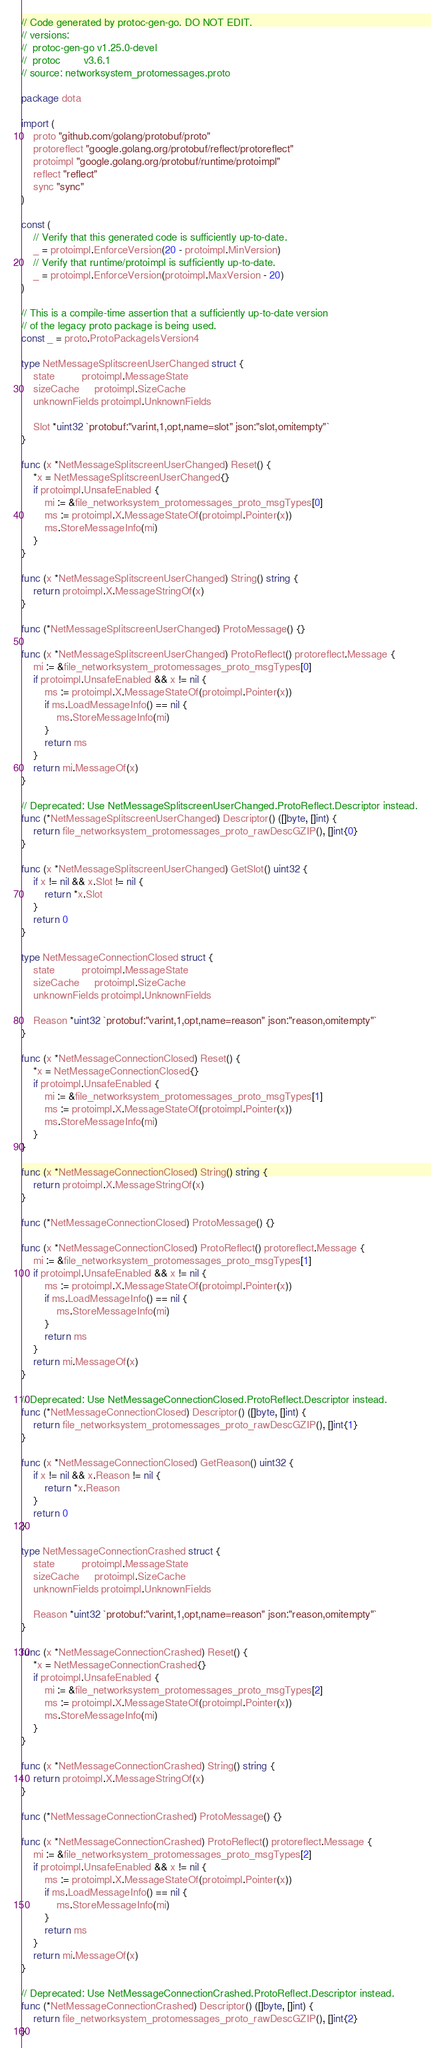<code> <loc_0><loc_0><loc_500><loc_500><_Go_>// Code generated by protoc-gen-go. DO NOT EDIT.
// versions:
// 	protoc-gen-go v1.25.0-devel
// 	protoc        v3.6.1
// source: networksystem_protomessages.proto

package dota

import (
	proto "github.com/golang/protobuf/proto"
	protoreflect "google.golang.org/protobuf/reflect/protoreflect"
	protoimpl "google.golang.org/protobuf/runtime/protoimpl"
	reflect "reflect"
	sync "sync"
)

const (
	// Verify that this generated code is sufficiently up-to-date.
	_ = protoimpl.EnforceVersion(20 - protoimpl.MinVersion)
	// Verify that runtime/protoimpl is sufficiently up-to-date.
	_ = protoimpl.EnforceVersion(protoimpl.MaxVersion - 20)
)

// This is a compile-time assertion that a sufficiently up-to-date version
// of the legacy proto package is being used.
const _ = proto.ProtoPackageIsVersion4

type NetMessageSplitscreenUserChanged struct {
	state         protoimpl.MessageState
	sizeCache     protoimpl.SizeCache
	unknownFields protoimpl.UnknownFields

	Slot *uint32 `protobuf:"varint,1,opt,name=slot" json:"slot,omitempty"`
}

func (x *NetMessageSplitscreenUserChanged) Reset() {
	*x = NetMessageSplitscreenUserChanged{}
	if protoimpl.UnsafeEnabled {
		mi := &file_networksystem_protomessages_proto_msgTypes[0]
		ms := protoimpl.X.MessageStateOf(protoimpl.Pointer(x))
		ms.StoreMessageInfo(mi)
	}
}

func (x *NetMessageSplitscreenUserChanged) String() string {
	return protoimpl.X.MessageStringOf(x)
}

func (*NetMessageSplitscreenUserChanged) ProtoMessage() {}

func (x *NetMessageSplitscreenUserChanged) ProtoReflect() protoreflect.Message {
	mi := &file_networksystem_protomessages_proto_msgTypes[0]
	if protoimpl.UnsafeEnabled && x != nil {
		ms := protoimpl.X.MessageStateOf(protoimpl.Pointer(x))
		if ms.LoadMessageInfo() == nil {
			ms.StoreMessageInfo(mi)
		}
		return ms
	}
	return mi.MessageOf(x)
}

// Deprecated: Use NetMessageSplitscreenUserChanged.ProtoReflect.Descriptor instead.
func (*NetMessageSplitscreenUserChanged) Descriptor() ([]byte, []int) {
	return file_networksystem_protomessages_proto_rawDescGZIP(), []int{0}
}

func (x *NetMessageSplitscreenUserChanged) GetSlot() uint32 {
	if x != nil && x.Slot != nil {
		return *x.Slot
	}
	return 0
}

type NetMessageConnectionClosed struct {
	state         protoimpl.MessageState
	sizeCache     protoimpl.SizeCache
	unknownFields protoimpl.UnknownFields

	Reason *uint32 `protobuf:"varint,1,opt,name=reason" json:"reason,omitempty"`
}

func (x *NetMessageConnectionClosed) Reset() {
	*x = NetMessageConnectionClosed{}
	if protoimpl.UnsafeEnabled {
		mi := &file_networksystem_protomessages_proto_msgTypes[1]
		ms := protoimpl.X.MessageStateOf(protoimpl.Pointer(x))
		ms.StoreMessageInfo(mi)
	}
}

func (x *NetMessageConnectionClosed) String() string {
	return protoimpl.X.MessageStringOf(x)
}

func (*NetMessageConnectionClosed) ProtoMessage() {}

func (x *NetMessageConnectionClosed) ProtoReflect() protoreflect.Message {
	mi := &file_networksystem_protomessages_proto_msgTypes[1]
	if protoimpl.UnsafeEnabled && x != nil {
		ms := protoimpl.X.MessageStateOf(protoimpl.Pointer(x))
		if ms.LoadMessageInfo() == nil {
			ms.StoreMessageInfo(mi)
		}
		return ms
	}
	return mi.MessageOf(x)
}

// Deprecated: Use NetMessageConnectionClosed.ProtoReflect.Descriptor instead.
func (*NetMessageConnectionClosed) Descriptor() ([]byte, []int) {
	return file_networksystem_protomessages_proto_rawDescGZIP(), []int{1}
}

func (x *NetMessageConnectionClosed) GetReason() uint32 {
	if x != nil && x.Reason != nil {
		return *x.Reason
	}
	return 0
}

type NetMessageConnectionCrashed struct {
	state         protoimpl.MessageState
	sizeCache     protoimpl.SizeCache
	unknownFields protoimpl.UnknownFields

	Reason *uint32 `protobuf:"varint,1,opt,name=reason" json:"reason,omitempty"`
}

func (x *NetMessageConnectionCrashed) Reset() {
	*x = NetMessageConnectionCrashed{}
	if protoimpl.UnsafeEnabled {
		mi := &file_networksystem_protomessages_proto_msgTypes[2]
		ms := protoimpl.X.MessageStateOf(protoimpl.Pointer(x))
		ms.StoreMessageInfo(mi)
	}
}

func (x *NetMessageConnectionCrashed) String() string {
	return protoimpl.X.MessageStringOf(x)
}

func (*NetMessageConnectionCrashed) ProtoMessage() {}

func (x *NetMessageConnectionCrashed) ProtoReflect() protoreflect.Message {
	mi := &file_networksystem_protomessages_proto_msgTypes[2]
	if protoimpl.UnsafeEnabled && x != nil {
		ms := protoimpl.X.MessageStateOf(protoimpl.Pointer(x))
		if ms.LoadMessageInfo() == nil {
			ms.StoreMessageInfo(mi)
		}
		return ms
	}
	return mi.MessageOf(x)
}

// Deprecated: Use NetMessageConnectionCrashed.ProtoReflect.Descriptor instead.
func (*NetMessageConnectionCrashed) Descriptor() ([]byte, []int) {
	return file_networksystem_protomessages_proto_rawDescGZIP(), []int{2}
}
</code> 